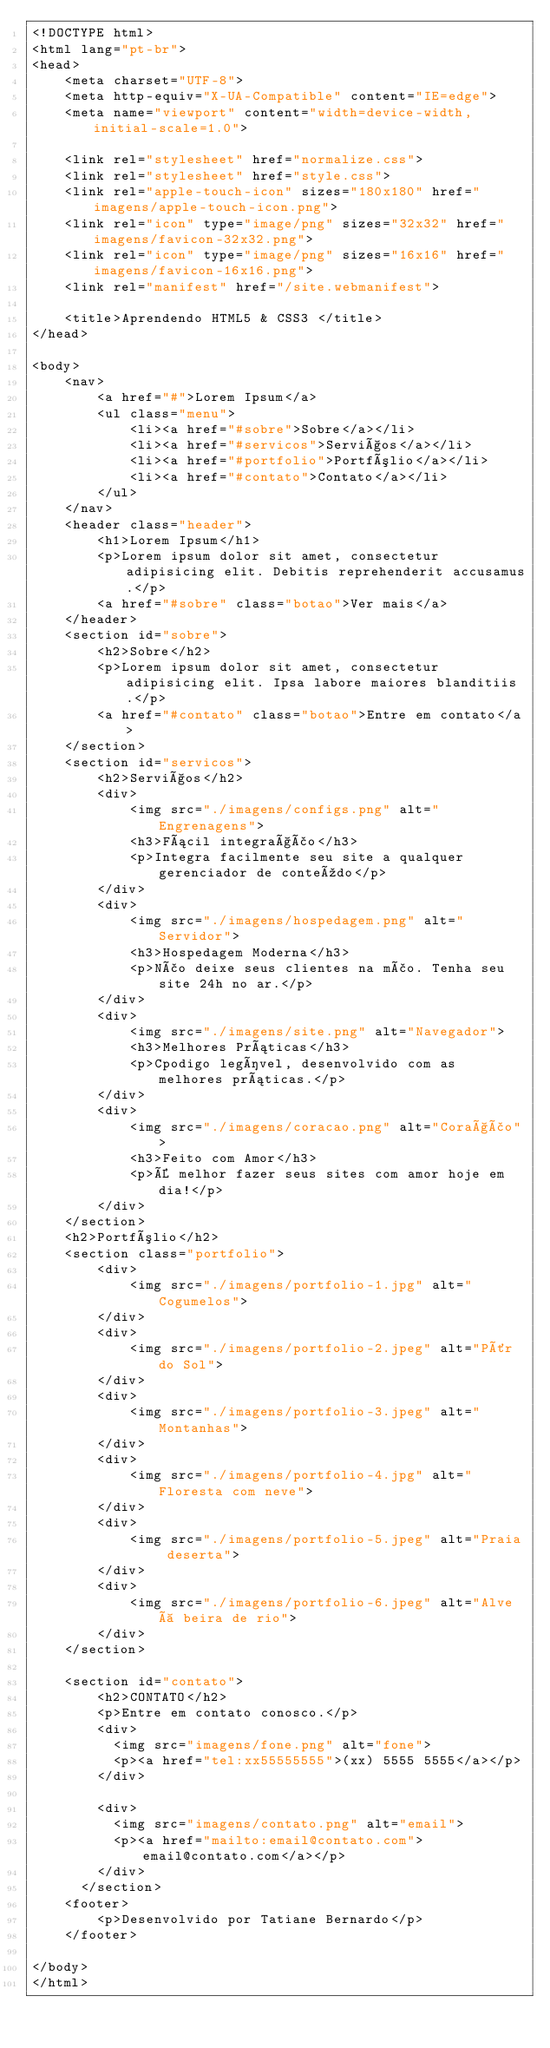Convert code to text. <code><loc_0><loc_0><loc_500><loc_500><_HTML_><!DOCTYPE html>
<html lang="pt-br">
<head>
	<meta charset="UTF-8">
	<meta http-equiv="X-UA-Compatible" content="IE=edge">
	<meta name="viewport" content="width=device-width, initial-scale=1.0">

	<link rel="stylesheet" href="normalize.css">
	<link rel="stylesheet" href="style.css">
	<link rel="apple-touch-icon" sizes="180x180" href="imagens/apple-touch-icon.png">
	<link rel="icon" type="image/png" sizes="32x32" href="imagens/favicon-32x32.png">
	<link rel="icon" type="image/png" sizes="16x16" href="imagens/favicon-16x16.png">
	<link rel="manifest" href="/site.webmanifest">

	<title>Aprendendo HTML5 & CSS3 </title>
</head>

<body>
	<nav>
		<a href="#">Lorem Ipsum</a>
		<ul class="menu">
			<li><a href="#sobre">Sobre</a></li>
			<li><a href="#servicos">Serviços</a></li>
			<li><a href="#portfolio">Portfólio</a></li>
			<li><a href="#contato">Contato</a></li>
		</ul>
	</nav>
	<header class="header">
		<h1>Lorem Ipsum</h1>
		<p>Lorem ipsum dolor sit amet, consectetur adipisicing elit. Debitis reprehenderit accusamus.</p>
		<a href="#sobre" class="botao">Ver mais</a>
	</header>
	<section id="sobre">
		<h2>Sobre</h2>
		<p>Lorem ipsum dolor sit amet, consectetur adipisicing elit. Ipsa labore maiores blanditiis.</p>
		<a href="#contato" class="botao">Entre em contato</a>
	</section>
	<section id="servicos">
		<h2>Serviços</h2>
		<div>
			<img src="./imagens/configs.png" alt="Engrenagens">
			<h3>Fácil integração</h3>
			<p>Integra facilmente seu site a qualquer gerenciador de conteúdo</p>
		</div>
		<div>
			<img src="./imagens/hospedagem.png" alt="Servidor">
			<h3>Hospedagem Moderna</h3>
			<p>Não deixe seus clientes na mão. Tenha seu site 24h no ar.</p>
		</div>
		<div>
			<img src="./imagens/site.png" alt="Navegador">
			<h3>Melhores Práticas</h3>
			<p>Cpodigo legível, desenvolvido com as melhores práticas.</p>
		</div>
		<div>
			<img src="./imagens/coracao.png" alt="Coração">
			<h3>Feito com Amor</h3>
			<p>É melhor fazer seus sites com amor hoje em dia!</p>
		</div>
	</section>
	<h2>Portfólio</h2>
	<section class="portfolio">
		<div>
			<img src="./imagens/portfolio-1.jpg" alt="Cogumelos">
		</div>
		<div>
			<img src="./imagens/portfolio-2.jpeg" alt="Pôr do Sol">
		</div>
		<div>
			<img src="./imagens/portfolio-3.jpeg" alt="Montanhas">
		</div>
		<div>
			<img src="./imagens/portfolio-4.jpg" alt="Floresta com neve">
		</div>
		<div>
			<img src="./imagens/portfolio-5.jpeg" alt="Praia deserta">
		</div>
		<div>
			<img src="./imagens/portfolio-6.jpeg" alt="Alve à beira de rio">
		</div>
	</section>

	<section id="contato">
		<h2>CONTATO</h2>
		<p>Entre em contato conosco.</p>
		<div>
		  <img src="imagens/fone.png" alt="fone">
		  <p><a href="tel:xx55555555">(xx) 5555 5555</a></p>
		</div>
		
		<div>
		  <img src="imagens/contato.png" alt="email">
		  <p><a href="mailto:email@contato.com">email@contato.com</a></p>
		</div>
	  </section>
	<footer>
		<p>Desenvolvido por Tatiane Bernardo</p>
	</footer>
	
</body>
</html></code> 